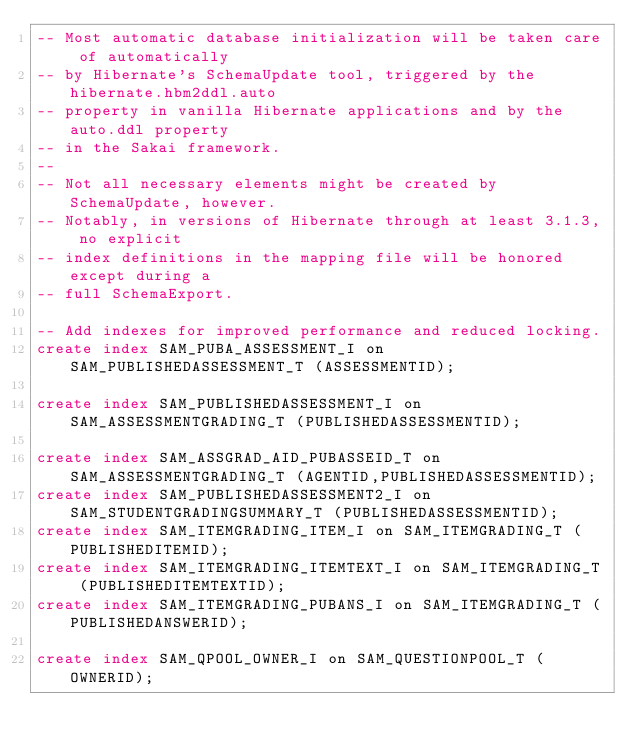<code> <loc_0><loc_0><loc_500><loc_500><_SQL_>-- Most automatic database initialization will be taken care of automatically
-- by Hibernate's SchemaUpdate tool, triggered by the hibernate.hbm2ddl.auto
-- property in vanilla Hibernate applications and by the auto.ddl property
-- in the Sakai framework.
--
-- Not all necessary elements might be created by SchemaUpdate, however.
-- Notably, in versions of Hibernate through at least 3.1.3, no explicit
-- index definitions in the mapping file will be honored except during a
-- full SchemaExport.

-- Add indexes for improved performance and reduced locking.
create index SAM_PUBA_ASSESSMENT_I on SAM_PUBLISHEDASSESSMENT_T (ASSESSMENTID);

create index SAM_PUBLISHEDASSESSMENT_I on SAM_ASSESSMENTGRADING_T (PUBLISHEDASSESSMENTID);

create index SAM_ASSGRAD_AID_PUBASSEID_T on SAM_ASSESSMENTGRADING_T (AGENTID,PUBLISHEDASSESSMENTID);
create index SAM_PUBLISHEDASSESSMENT2_I on SAM_STUDENTGRADINGSUMMARY_T (PUBLISHEDASSESSMENTID);
create index SAM_ITEMGRADING_ITEM_I on SAM_ITEMGRADING_T (PUBLISHEDITEMID);
create index SAM_ITEMGRADING_ITEMTEXT_I on SAM_ITEMGRADING_T (PUBLISHEDITEMTEXTID);
create index SAM_ITEMGRADING_PUBANS_I on SAM_ITEMGRADING_T (PUBLISHEDANSWERID);

create index SAM_QPOOL_OWNER_I on SAM_QUESTIONPOOL_T (OWNERID);
</code> 